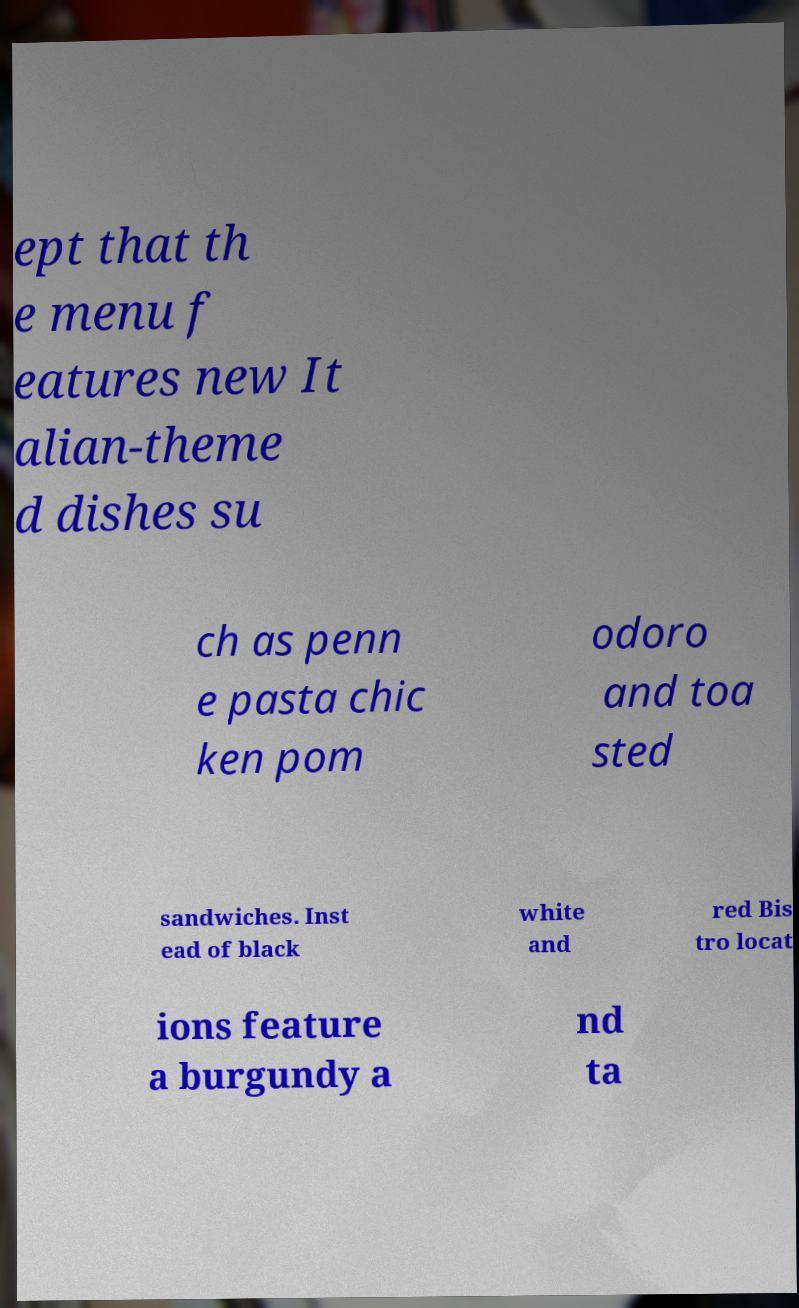Can you accurately transcribe the text from the provided image for me? ept that th e menu f eatures new It alian-theme d dishes su ch as penn e pasta chic ken pom odoro and toa sted sandwiches. Inst ead of black white and red Bis tro locat ions feature a burgundy a nd ta 